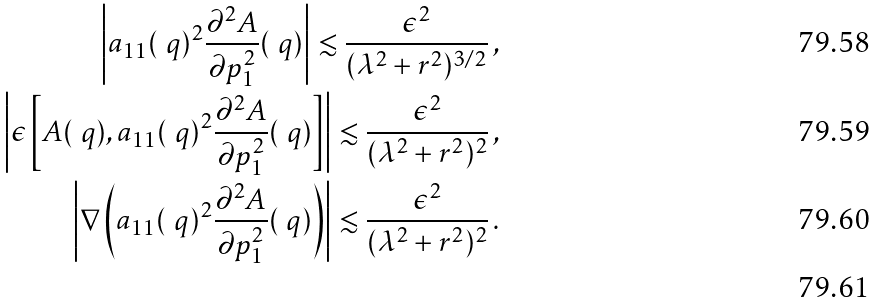<formula> <loc_0><loc_0><loc_500><loc_500>\left | a _ { 1 1 } ( \ q ) ^ { 2 } \frac { \partial ^ { 2 } A } { \partial p _ { 1 } ^ { 2 } } ( \ q ) \right | \lesssim \frac { \epsilon ^ { 2 } } { ( \lambda ^ { 2 } + r ^ { 2 } ) ^ { 3 / 2 } } \, , \\ \left | \epsilon \left [ A ( \ q ) , a _ { 1 1 } ( \ q ) ^ { 2 } \frac { \partial ^ { 2 } A } { \partial p _ { 1 } ^ { 2 } } ( \ q ) \right ] \right | \lesssim \frac { \epsilon ^ { 2 } } { ( \lambda ^ { 2 } + r ^ { 2 } ) ^ { 2 } } \, , \\ \left | \nabla \left ( a _ { 1 1 } ( \ q ) ^ { 2 } \frac { \partial ^ { 2 } A } { \partial p _ { 1 } ^ { 2 } } ( \ q ) \right ) \right | \lesssim \frac { \epsilon ^ { 2 } } { ( \lambda ^ { 2 } + r ^ { 2 } ) ^ { 2 } } \, . \\</formula> 